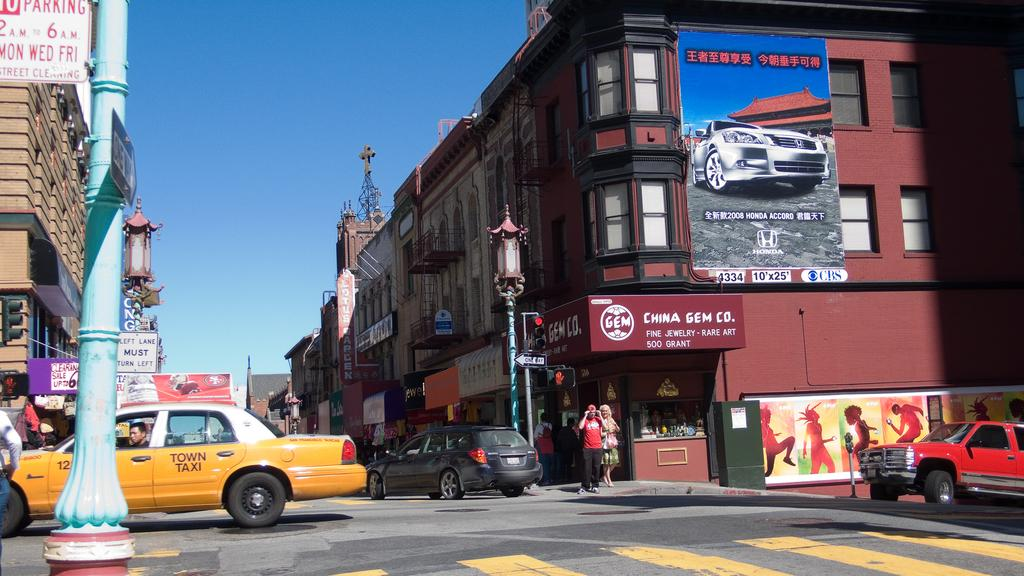<image>
Offer a succinct explanation of the picture presented. A brown building with a sign that says CHINA GEM CO. Fine Jewelry - rare art. 